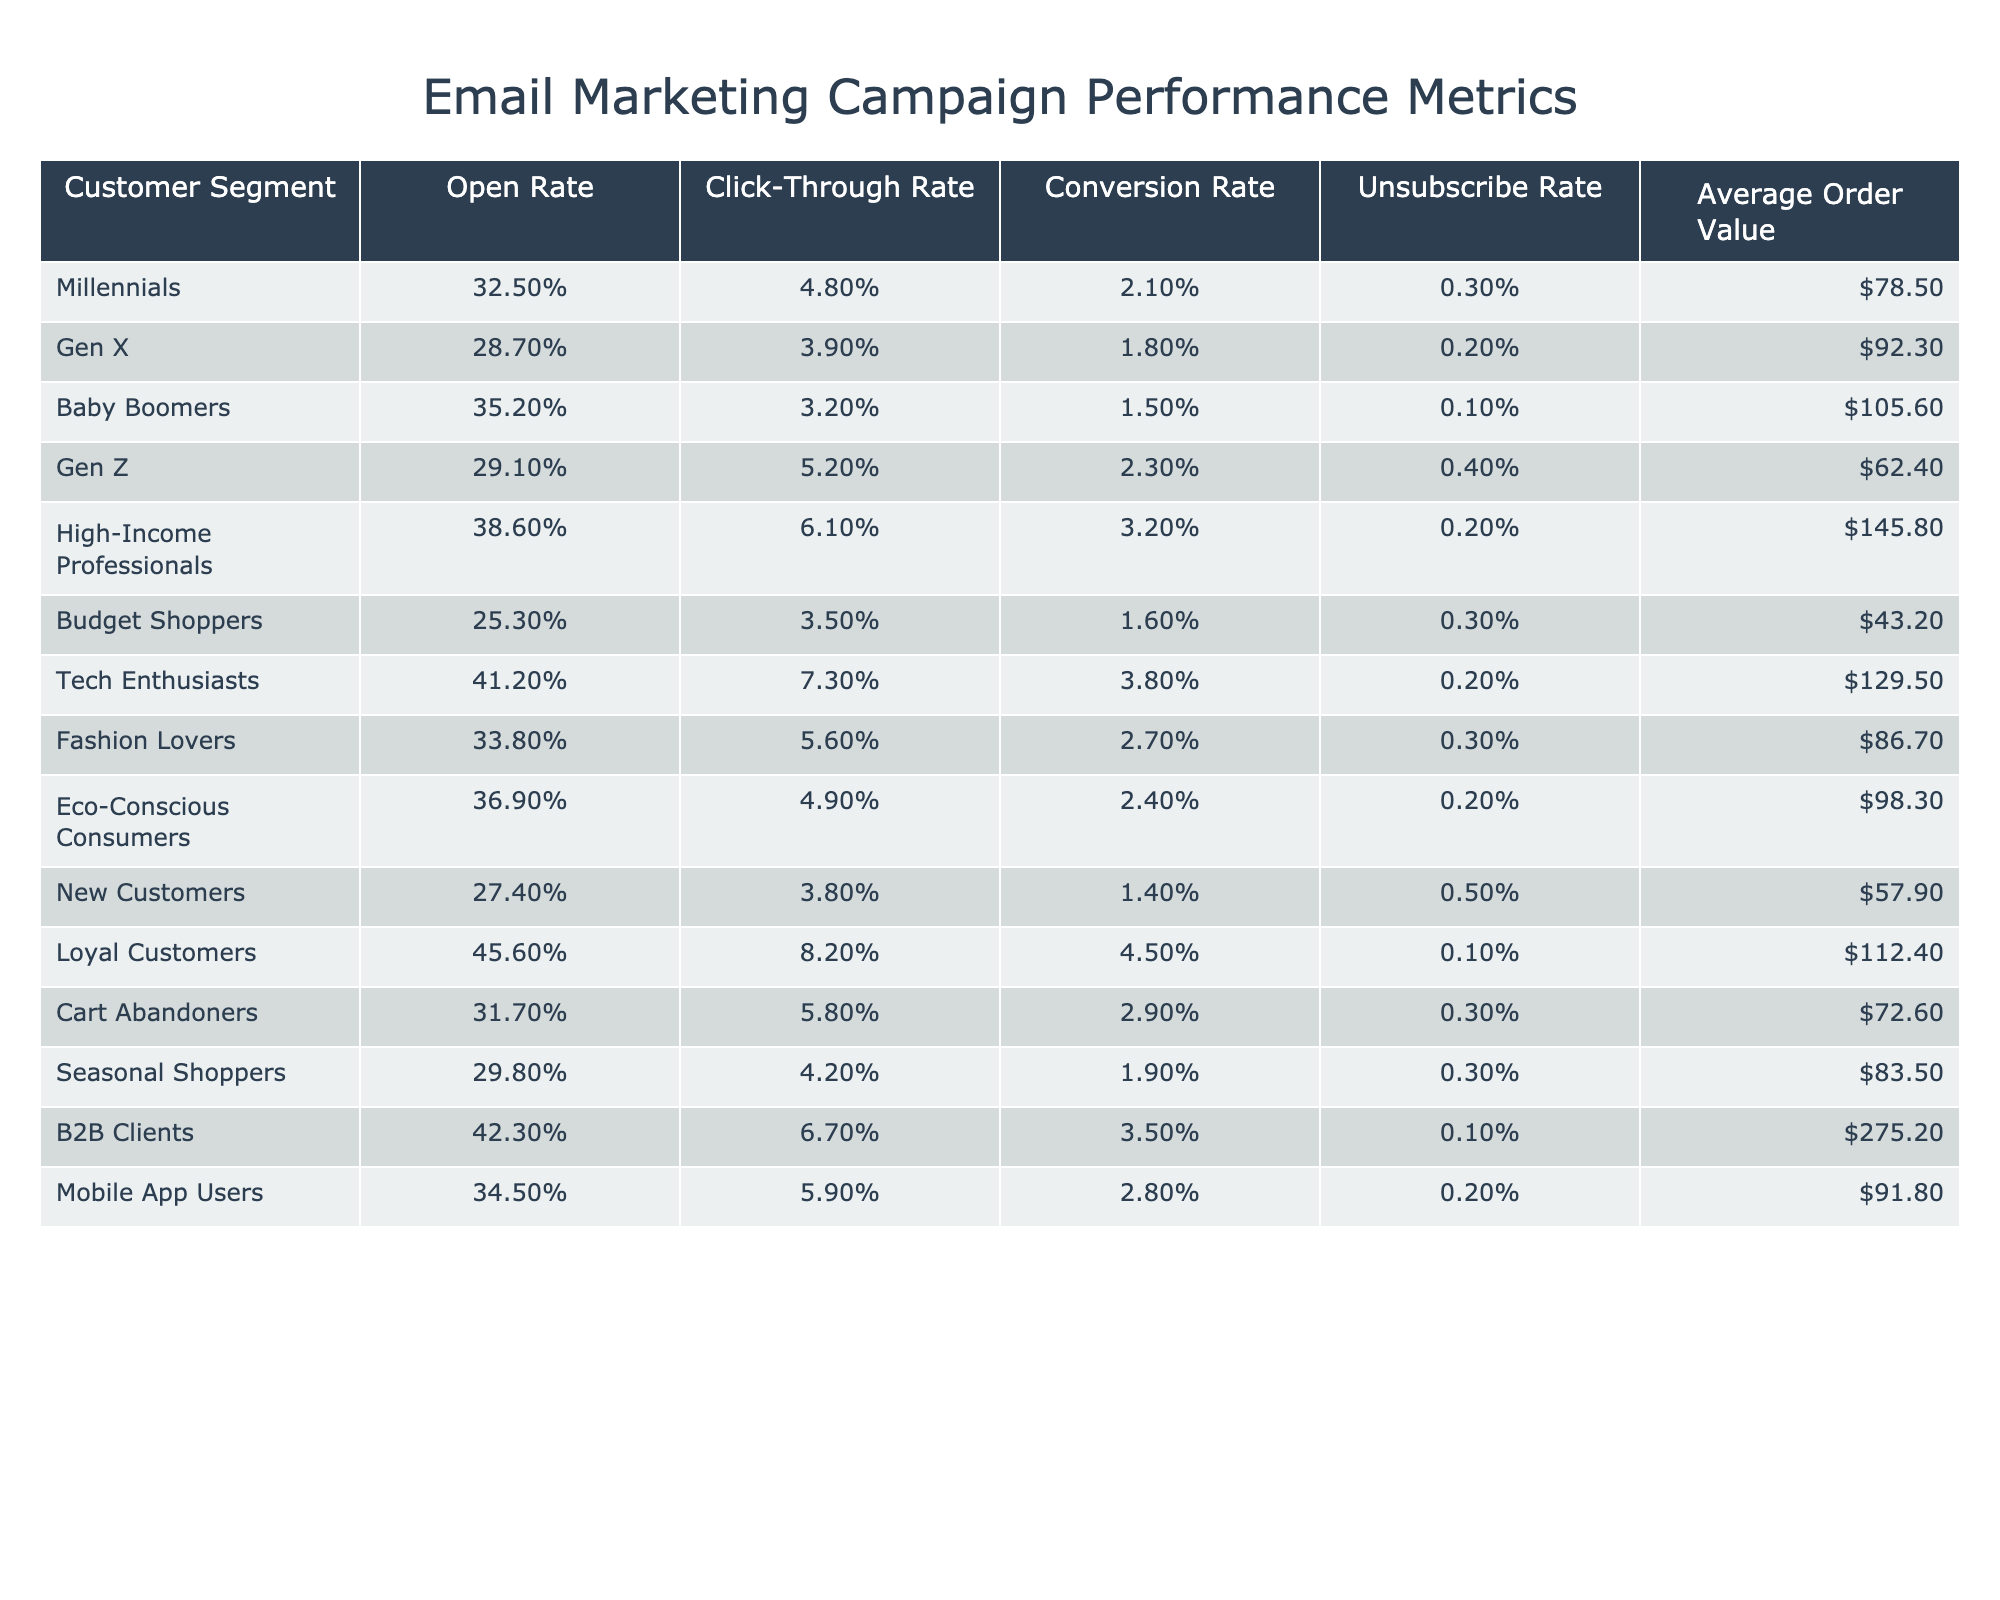What is the Open Rate for Tech Enthusiasts? The table shows that the Open Rate for Tech Enthusiasts is listed as 41.2%.
Answer: 41.2% Which customer segment has the highest Conversion Rate? By comparing the Conversion Rates of each segment, High-Income Professionals has the highest at 3.2%.
Answer: High-Income Professionals What is the difference in Average Order Value between B2B Clients and Budget Shoppers? B2B Clients have an Average Order Value of $275.20 and Budget Shoppers have $43.20. The difference is calculated as $275.20 - $43.20 = $232.00.
Answer: $232.00 Is the Unsubscribe Rate for Baby Boomers lower than that for Millennials? The Unsubscribe Rate for Baby Boomers is 0.1% and for Millennials is 0.3%. Since 0.1% is less than 0.3%, the statement is true.
Answer: Yes What is the average Open Rate for Loyal Customers and High-Income Professionals? Loyal Customers have an Open Rate of 45.6% and High-Income Professionals have 38.6%. To find the average, we add these rates: 45.6% + 38.6% = 84.2% and divide by 2, resulting in 42.1%.
Answer: 42.1% Which segment has the highest Click-Through Rate and what is that rate? The Click-Through Rate for Tech Enthusiasts is listed as 7.3%, which is the highest among all segments.
Answer: Tech Enthusiasts, 7.3% How does the Conversion Rate for New Customers compare to that of Loyal Customers? New Customers have a Conversion Rate of 1.4% while Loyal Customers have 4.5%. Since 1.4% is less than 4.5%, the Conversion Rate for New Customers is significantly lower.
Answer: Lower What is the total Unsubscribe Rate for Millennials, Gen Z, and Cart Abandoners? The Unsubscribe Rates are 0.3% for Millennials, 0.4% for Gen Z, and 0.3% for Cart Abandoners. Adding these together gives a total of 0.3% + 0.4% + 0.3% = 1.0%.
Answer: 1.0% Are Eco-Conscious Consumers more likely to Convert compared to Budget Shoppers? Eco-Conscious Consumers have a Conversion Rate of 2.4% while Budget Shoppers have 1.6%, indicating that Eco-Conscious Consumers are more likely to Convert.
Answer: Yes What customer segment has the lowest Click-Through Rate? Budget Shoppers have the lowest Click-Through Rate of 3.5% compared to the other segments listed.
Answer: Budget Shoppers What is the total Average Order Value for Fashion Lovers and Eco-Conscious Consumers? The Average Order Value for Fashion Lovers is $86.70 and for Eco-Conscious Consumers is $98.30. Adding these amounts together gives $86.70 + $98.30 = $185.00.
Answer: $185.00 